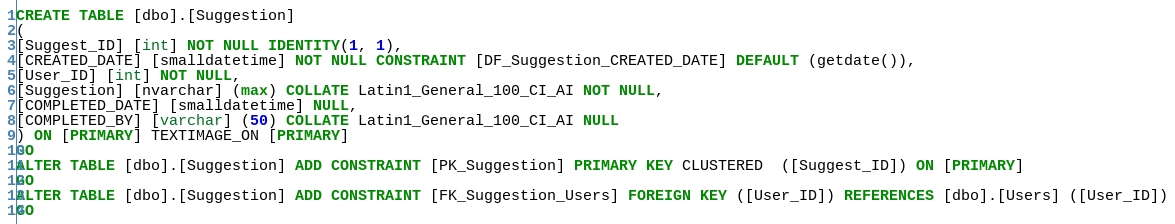<code> <loc_0><loc_0><loc_500><loc_500><_SQL_>CREATE TABLE [dbo].[Suggestion]
(
[Suggest_ID] [int] NOT NULL IDENTITY(1, 1),
[CREATED_DATE] [smalldatetime] NOT NULL CONSTRAINT [DF_Suggestion_CREATED_DATE] DEFAULT (getdate()),
[User_ID] [int] NOT NULL,
[Suggestion] [nvarchar] (max) COLLATE Latin1_General_100_CI_AI NOT NULL,
[COMPLETED_DATE] [smalldatetime] NULL,
[COMPLETED_BY] [varchar] (50) COLLATE Latin1_General_100_CI_AI NULL
) ON [PRIMARY] TEXTIMAGE_ON [PRIMARY]
GO
ALTER TABLE [dbo].[Suggestion] ADD CONSTRAINT [PK_Suggestion] PRIMARY KEY CLUSTERED  ([Suggest_ID]) ON [PRIMARY]
GO
ALTER TABLE [dbo].[Suggestion] ADD CONSTRAINT [FK_Suggestion_Users] FOREIGN KEY ([User_ID]) REFERENCES [dbo].[Users] ([User_ID])
GO
</code> 